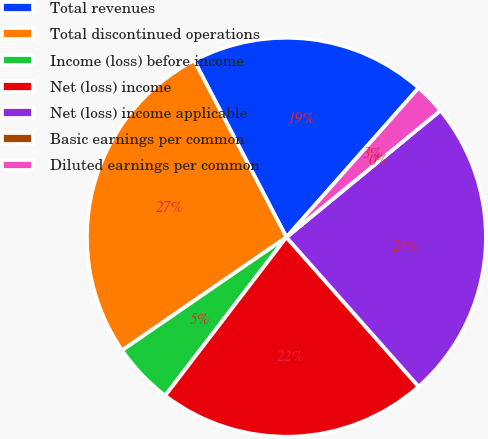Convert chart to OTSL. <chart><loc_0><loc_0><loc_500><loc_500><pie_chart><fcel>Total revenues<fcel>Total discontinued operations<fcel>Income (loss) before income<fcel>Net (loss) income<fcel>Net (loss) income applicable<fcel>Basic earnings per common<fcel>Diluted earnings per common<nl><fcel>19.19%<fcel>26.94%<fcel>5.01%<fcel>21.93%<fcel>24.43%<fcel>0.0%<fcel>2.51%<nl></chart> 